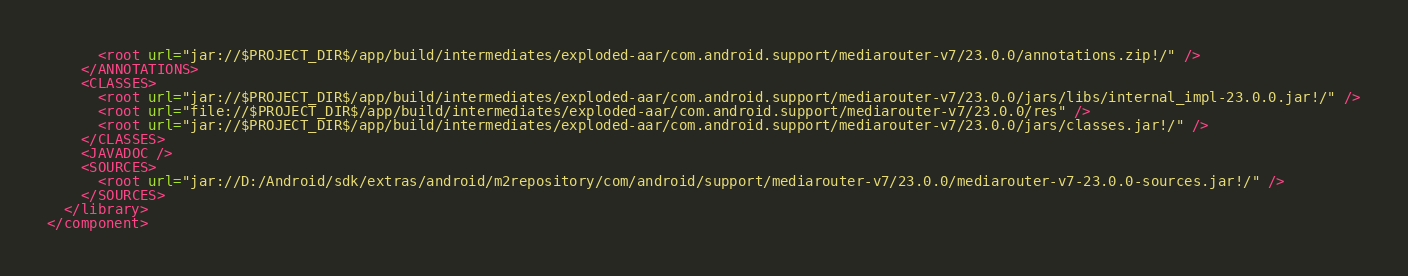Convert code to text. <code><loc_0><loc_0><loc_500><loc_500><_XML_>      <root url="jar://$PROJECT_DIR$/app/build/intermediates/exploded-aar/com.android.support/mediarouter-v7/23.0.0/annotations.zip!/" />
    </ANNOTATIONS>
    <CLASSES>
      <root url="jar://$PROJECT_DIR$/app/build/intermediates/exploded-aar/com.android.support/mediarouter-v7/23.0.0/jars/libs/internal_impl-23.0.0.jar!/" />
      <root url="file://$PROJECT_DIR$/app/build/intermediates/exploded-aar/com.android.support/mediarouter-v7/23.0.0/res" />
      <root url="jar://$PROJECT_DIR$/app/build/intermediates/exploded-aar/com.android.support/mediarouter-v7/23.0.0/jars/classes.jar!/" />
    </CLASSES>
    <JAVADOC />
    <SOURCES>
      <root url="jar://D:/Android/sdk/extras/android/m2repository/com/android/support/mediarouter-v7/23.0.0/mediarouter-v7-23.0.0-sources.jar!/" />
    </SOURCES>
  </library>
</component></code> 